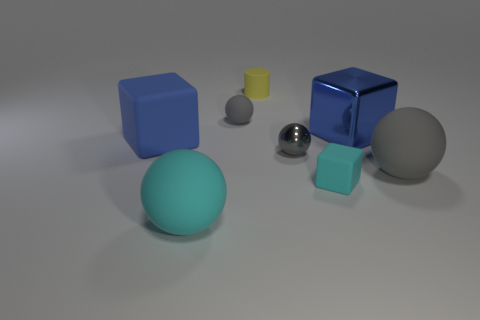What number of things are tiny things left of the small cyan block or blue cubes in front of the large shiny object?
Your response must be concise. 4. There is a tiny gray thing behind the blue object in front of the blue metal object; what is its shape?
Your answer should be very brief. Sphere. Is there a yellow ball that has the same material as the cylinder?
Keep it short and to the point. No. There is a small rubber object that is the same shape as the blue metal thing; what is its color?
Make the answer very short. Cyan. Is the number of yellow rubber cylinders in front of the cyan matte cube less than the number of rubber cylinders that are right of the gray shiny thing?
Provide a short and direct response. No. What number of other things are there of the same shape as the big gray object?
Make the answer very short. 3. Are there fewer tiny shiny spheres to the right of the gray metal object than large cyan balls?
Provide a short and direct response. Yes. There is a large blue block left of the large cyan rubber sphere; what is it made of?
Give a very brief answer. Rubber. How many other objects are the same size as the blue matte thing?
Make the answer very short. 3. Is the number of yellow rubber cylinders less than the number of blocks?
Provide a succinct answer. Yes. 